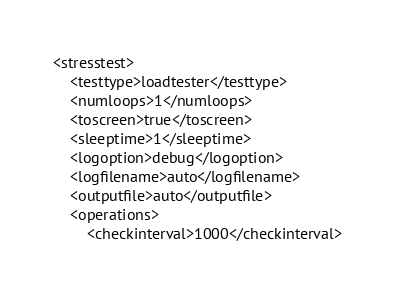Convert code to text. <code><loc_0><loc_0><loc_500><loc_500><_XML_><stresstest>
	<testtype>loadtester</testtype>
	<numloops>1</numloops>
	<toscreen>true</toscreen>
	<sleeptime>1</sleeptime>
	<logoption>debug</logoption>
	<logfilename>auto</logfilename>
	<outputfile>auto</outputfile>
	<operations>
		<checkinterval>1000</checkinterval></code> 